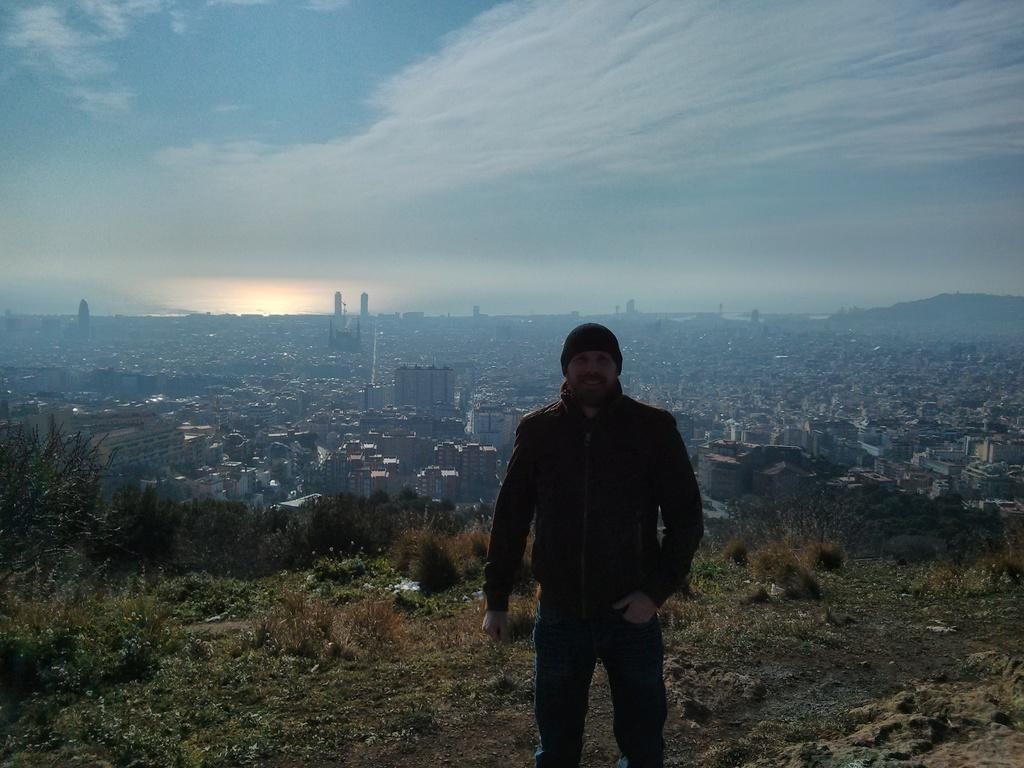What is the main subject of the image? There is a person standing in the image. What is the person wearing? The person is wearing clothes and a cap. What type of terrain is visible in the image? There is grass visible in the image. What type of structures can be seen in the image? There are buildings in the image. What geographical feature is present in the image? There is a hill in the image. What is the weather like in the image? The sky is cloudy in the image. Where is the tent located in the image? There is no tent present in the image. What type of sack is being carried by the person in the image? There is no sack visible in the image. 